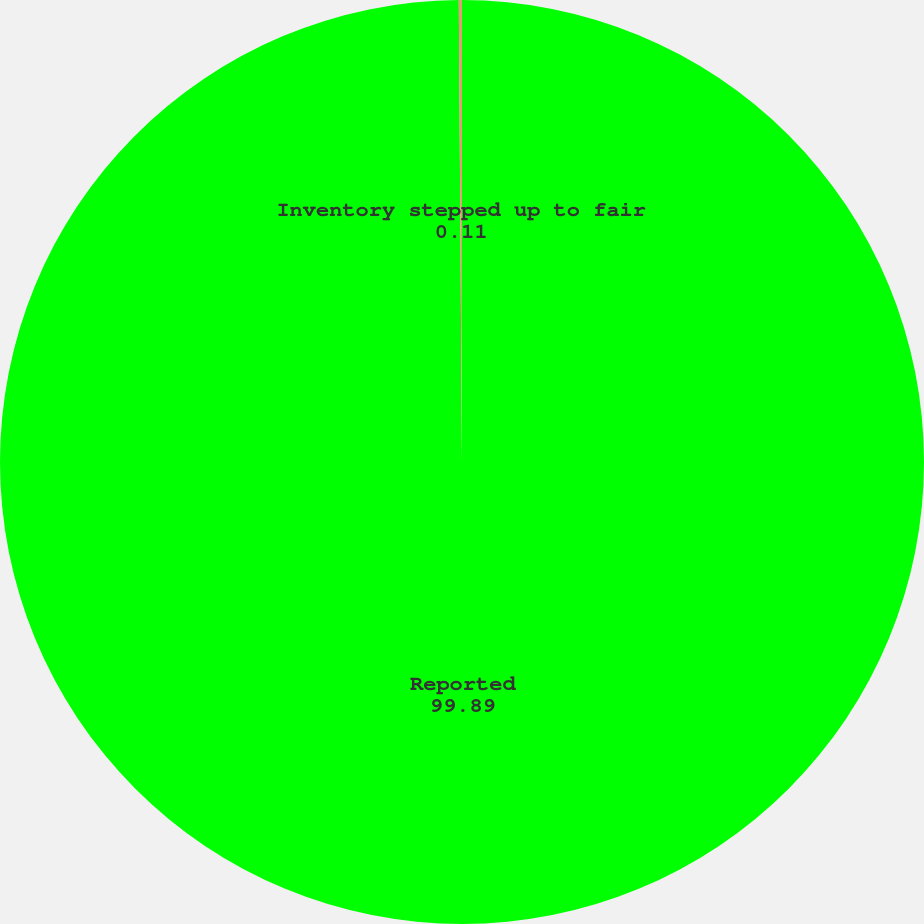<chart> <loc_0><loc_0><loc_500><loc_500><pie_chart><fcel>Reported<fcel>Inventory stepped up to fair<nl><fcel>99.89%<fcel>0.11%<nl></chart> 